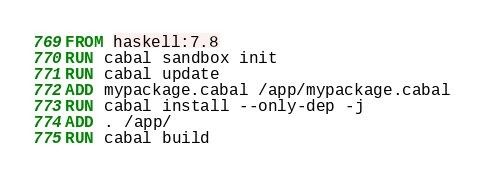Convert code to text. <code><loc_0><loc_0><loc_500><loc_500><_Dockerfile_>FROM haskell:7.8
RUN cabal sandbox init
RUN cabal update
ADD mypackage.cabal /app/mypackage.cabal
RUN cabal install --only-dep -j
ADD . /app/
RUN cabal build
</code> 